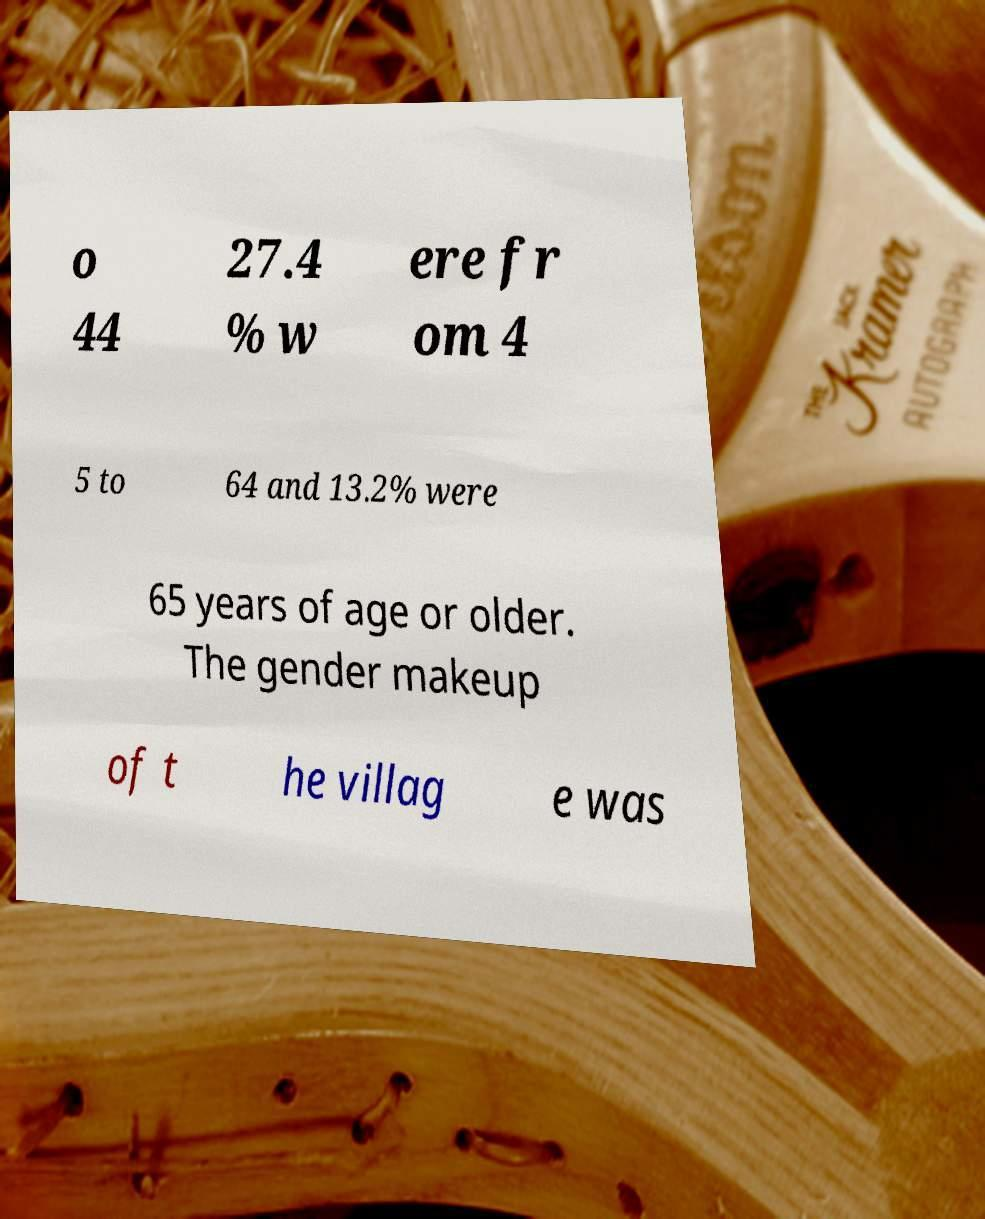Can you accurately transcribe the text from the provided image for me? o 44 27.4 % w ere fr om 4 5 to 64 and 13.2% were 65 years of age or older. The gender makeup of t he villag e was 